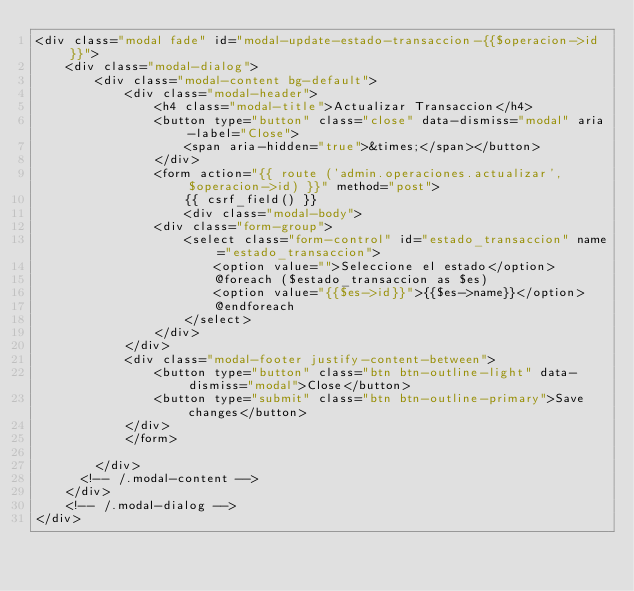Convert code to text. <code><loc_0><loc_0><loc_500><loc_500><_PHP_><div class="modal fade" id="modal-update-estado-transaccion-{{$operacion->id}}">
    <div class="modal-dialog">
        <div class="modal-content bg-default">
            <div class="modal-header">
                <h4 class="modal-title">Actualizar Transaccion</h4>
                <button type="button" class="close" data-dismiss="modal" aria-label="Close">
                    <span aria-hidden="true">&times;</span></button>
                </div>
                <form action="{{ route ('admin.operaciones.actualizar', $operacion->id) }}" method="post">
                    {{ csrf_field() }}
                    <div class="modal-body">          
                <div class="form-group">
                    <select class="form-control" id="estado_transaccion" name="estado_transaccion">
                        <option value="">Seleccione el estado</option>
                        @foreach ($estado_transaccion as $es)
                        <option value="{{$es->id}}">{{$es->name}}</option>
                        @endforeach
                    </select>
                </div>
            </div>
            <div class="modal-footer justify-content-between">
                <button type="button" class="btn btn-outline-light" data-dismiss="modal">Close</button>
                <button type="submit" class="btn btn-outline-primary">Save changes</button>
            </div>
            </form>
            
        </div>
      <!-- /.modal-content -->
    </div>
    <!-- /.modal-dialog -->
</div></code> 